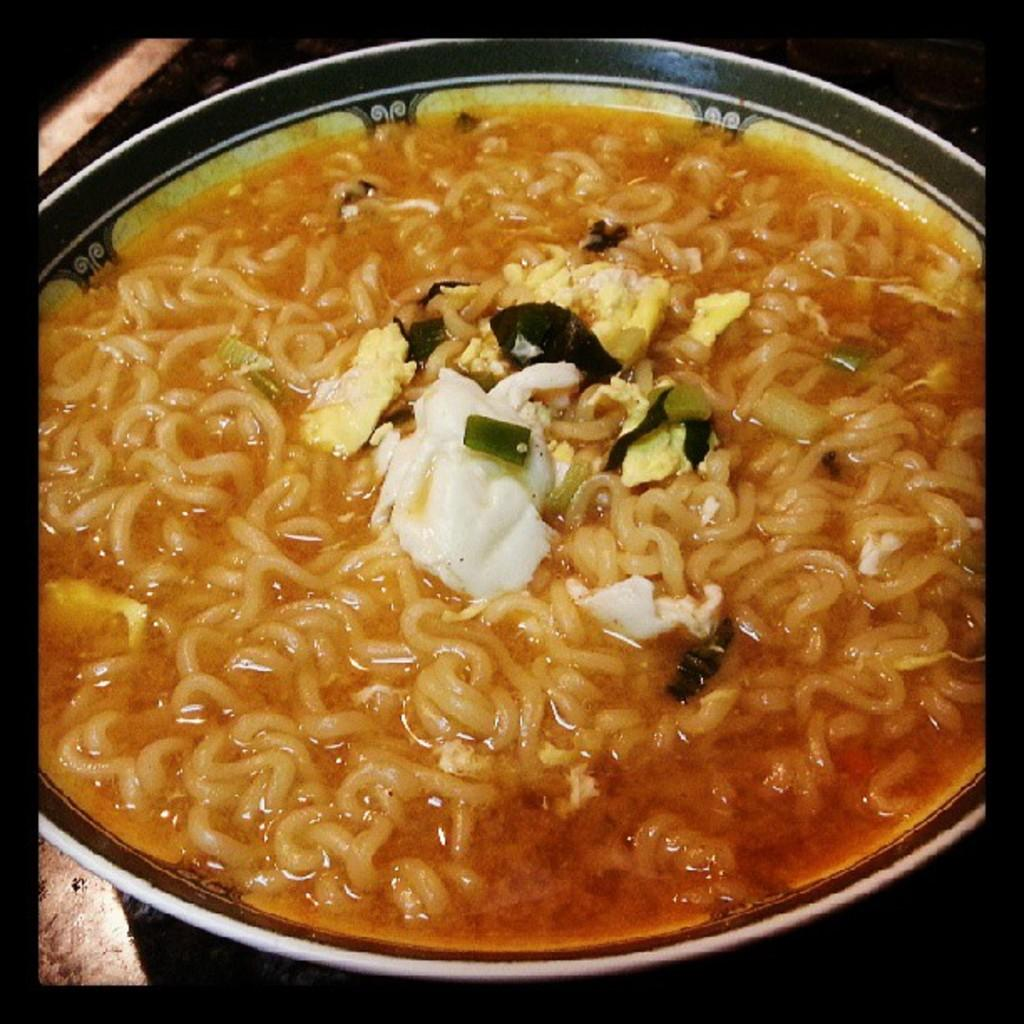What is in the bowl that is visible in the image? The bowl contains noodles. Where is the bowl located in the image? The bowl is placed on a table. What is the color of the table in the image? The table is black in color. Can you see a zebra using a crayon to perform magic tricks in the image? No, there is no zebra, crayon, or magic tricks present in the image. 